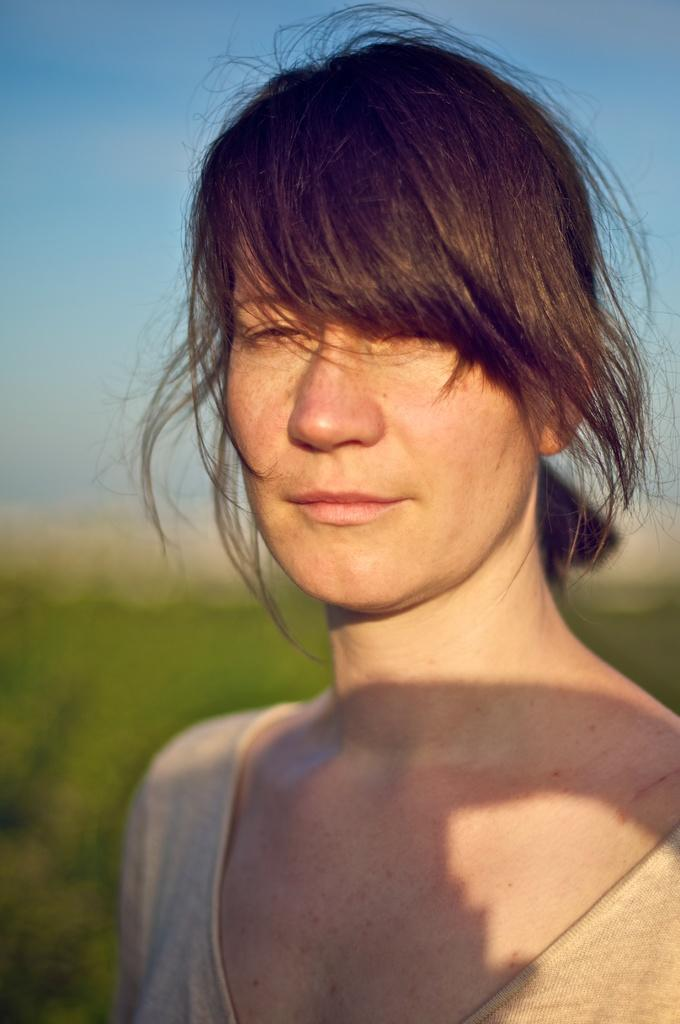Who is the main subject in the image? There is a woman in the image. What can be observed about the background of the image? The background of the image is blurred. What colors are visible in the image? Green and blue colors are present in the image. What type of power does the father demonstrate in the image? There is no father present in the image, and therefore no power can be attributed to a father. 